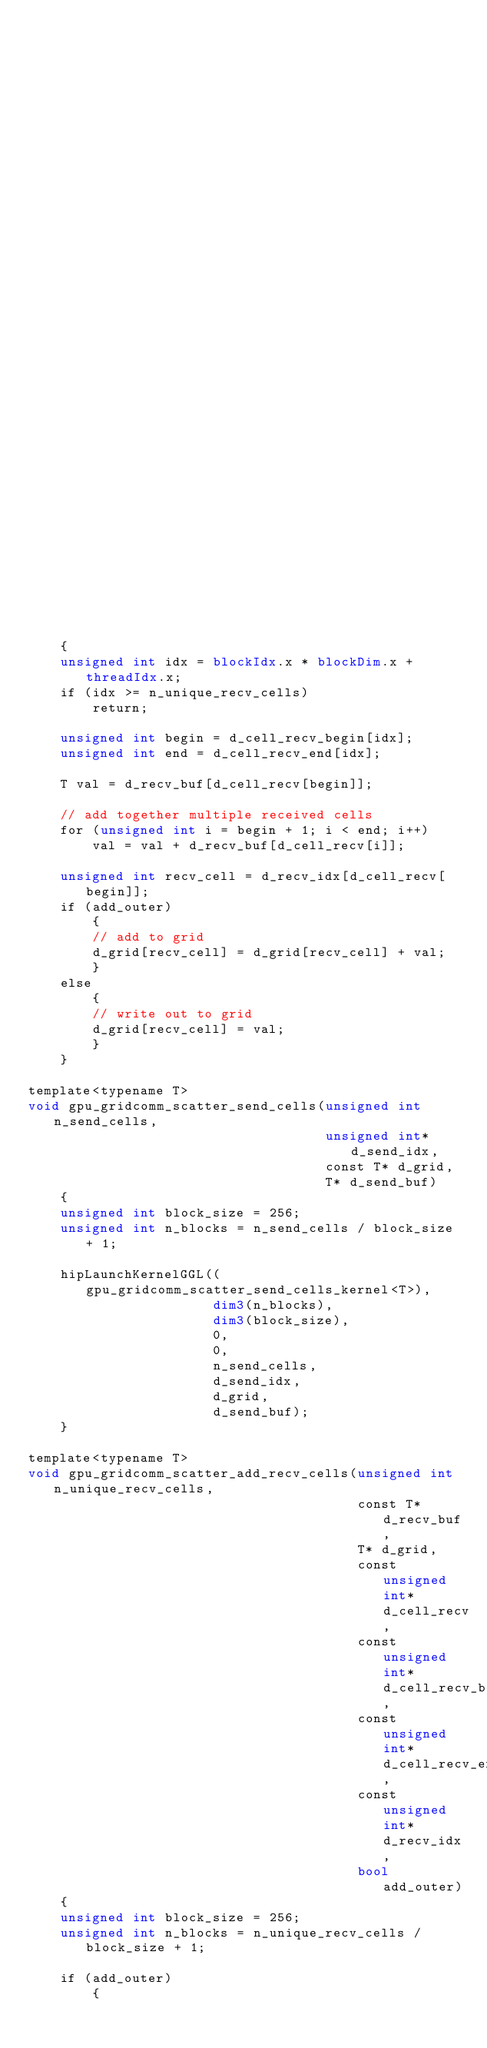Convert code to text. <code><loc_0><loc_0><loc_500><loc_500><_Cuda_>                                                           const unsigned int* d_cell_recv,
                                                           const unsigned int* d_cell_recv_begin,
                                                           const unsigned int* d_cell_recv_end,
                                                           const unsigned int* d_recv_idx)
    {
    unsigned int idx = blockIdx.x * blockDim.x + threadIdx.x;
    if (idx >= n_unique_recv_cells)
        return;

    unsigned int begin = d_cell_recv_begin[idx];
    unsigned int end = d_cell_recv_end[idx];

    T val = d_recv_buf[d_cell_recv[begin]];

    // add together multiple received cells
    for (unsigned int i = begin + 1; i < end; i++)
        val = val + d_recv_buf[d_cell_recv[i]];

    unsigned int recv_cell = d_recv_idx[d_cell_recv[begin]];
    if (add_outer)
        {
        // add to grid
        d_grid[recv_cell] = d_grid[recv_cell] + val;
        }
    else
        {
        // write out to grid
        d_grid[recv_cell] = val;
        }
    }

template<typename T>
void gpu_gridcomm_scatter_send_cells(unsigned int n_send_cells,
                                     unsigned int* d_send_idx,
                                     const T* d_grid,
                                     T* d_send_buf)
    {
    unsigned int block_size = 256;
    unsigned int n_blocks = n_send_cells / block_size + 1;

    hipLaunchKernelGGL((gpu_gridcomm_scatter_send_cells_kernel<T>),
                       dim3(n_blocks),
                       dim3(block_size),
                       0,
                       0,
                       n_send_cells,
                       d_send_idx,
                       d_grid,
                       d_send_buf);
    }

template<typename T>
void gpu_gridcomm_scatter_add_recv_cells(unsigned int n_unique_recv_cells,
                                         const T* d_recv_buf,
                                         T* d_grid,
                                         const unsigned int* d_cell_recv,
                                         const unsigned int* d_cell_recv_begin,
                                         const unsigned int* d_cell_recv_end,
                                         const unsigned int* d_recv_idx,
                                         bool add_outer)
    {
    unsigned int block_size = 256;
    unsigned int n_blocks = n_unique_recv_cells / block_size + 1;

    if (add_outer)
        {</code> 